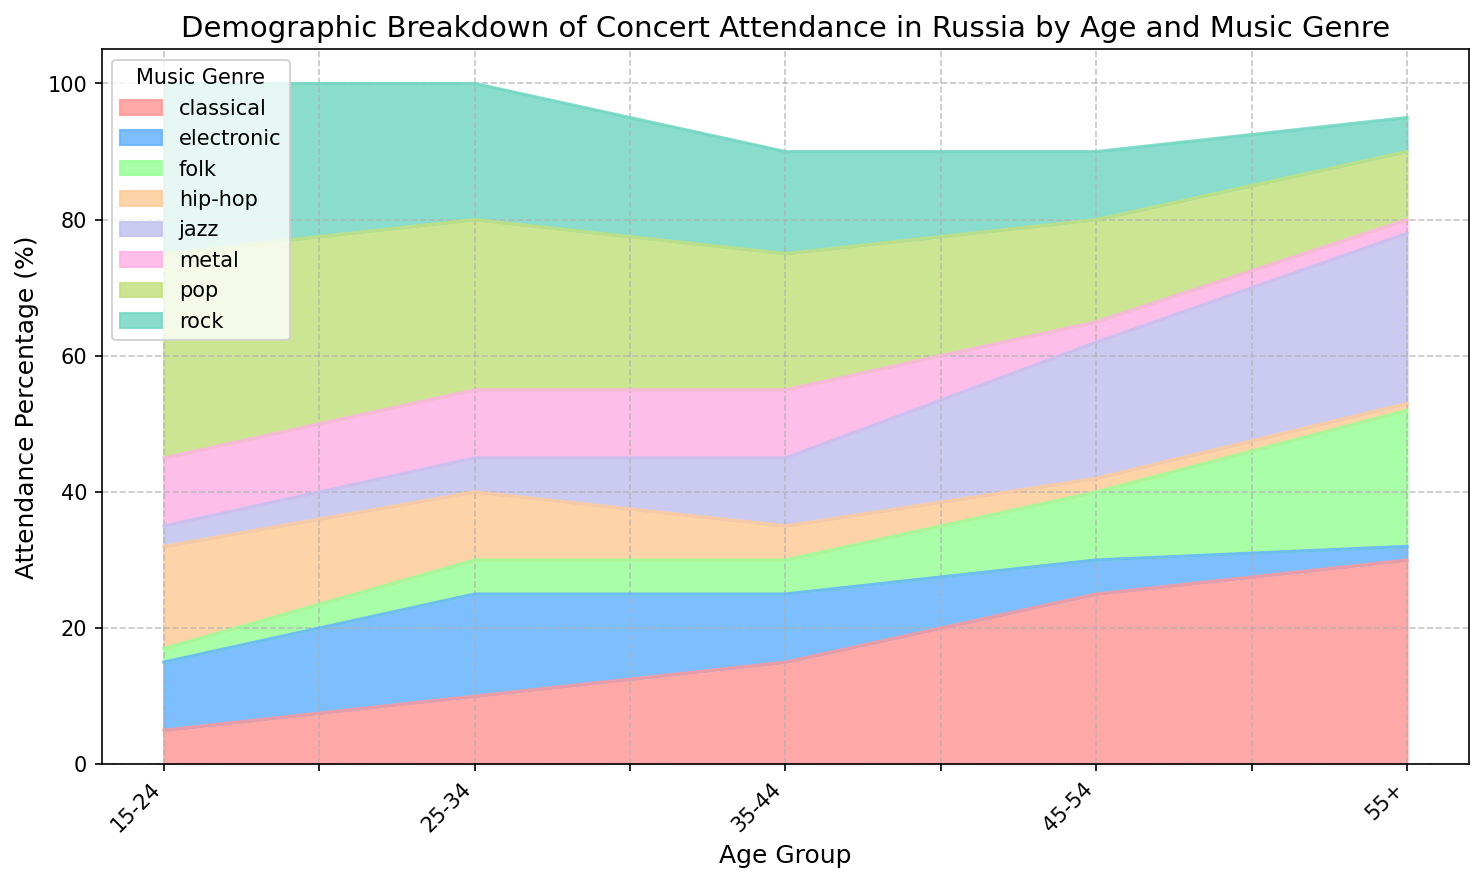Which age group has the highest attendance percentage for classical music? By looking at the area chart, observe the segment representing classical music (one color) and identify which age group has the highest height for that section. The highest value is for the age group 55+.
Answer: 55+ How does the attendance percentage for rock music in the 15-24 age group compare to the 25-34 age group? Find the rock music segment for 15-24 and 25-34 age groups in the area chart. Compare their heights visually. The 15-24 group is taller than the 25-34 group.
Answer: Higher Which music genre has the smallest attendance percentage for the 35-44 age group? Look at the segments for the 35-44 age group and identify the smallest section, which corresponds to folk music.
Answer: Folk Which age group has the highest total attendance for pop and classical music combined? Calculate the combined height of the pop and classical segments for each age group. Compare these values across all age groups. The highest combined value is for the 55+ age group.
Answer: 55+ Between electronic and jazz music, which genre has a more consistent attendance across all age groups? Assess the heights of the electronic and jazz segments across all age groups. Jazz music appears to have a more consistent height compared to electronic music.
Answer: Jazz What is the difference in the attendance percentage for hip-hop music between the 15-24 and 45-54 age groups? Subtract the height of the hip-hop section in the 45-54 age group from the height of the hip-hop section in the 15-24 age group. The difference is 15 - 2.
Answer: 13 What is the average attendance percentage for metal music across all age groups? Sum the attendance percentages for metal music across all age groups and divide by the number of age groups (8+10+10+3+2). The average is (10+10+10+3+2)/5.
Answer: 7 Which genre has the highest attendance in the 25-34 age group, and what is its percentage? Identify the tallest segment for the 25-34 age group. The tallest section corresponds to pop music with a percentage of 25%.
Answer: Pop, 25% What is the total attendance percentage for folk music in the 15-24 and 35-44 age groups? Sum the heights of the folk sections for the 15-24 and 35-44 age groups. The total is 2 + 5.
Answer: 7 Which age group has the lowest attendance percentage for jazz music? Compare the heights of the jazz segments across all age groups. The lowest percentage for jazz music is in the 15-24 age group.
Answer: 15-24 